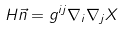<formula> <loc_0><loc_0><loc_500><loc_500>H \vec { n } = g ^ { i j } \nabla _ { i } \nabla _ { j } X</formula> 